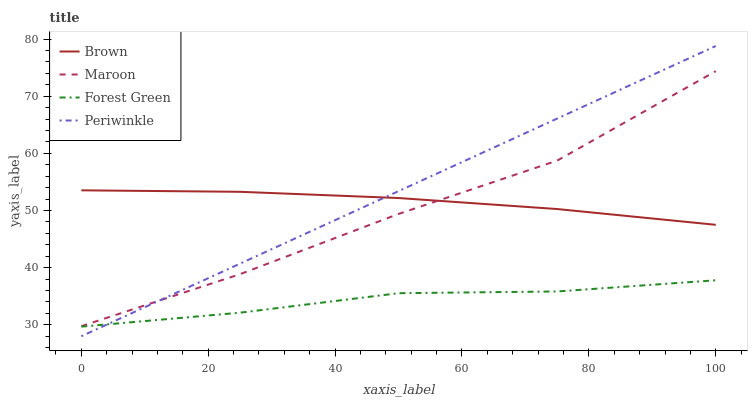Does Periwinkle have the minimum area under the curve?
Answer yes or no. No. Does Forest Green have the maximum area under the curve?
Answer yes or no. No. Is Forest Green the smoothest?
Answer yes or no. No. Is Forest Green the roughest?
Answer yes or no. No. Does Forest Green have the lowest value?
Answer yes or no. No. Does Forest Green have the highest value?
Answer yes or no. No. Is Forest Green less than Brown?
Answer yes or no. Yes. Is Brown greater than Forest Green?
Answer yes or no. Yes. Does Forest Green intersect Brown?
Answer yes or no. No. 